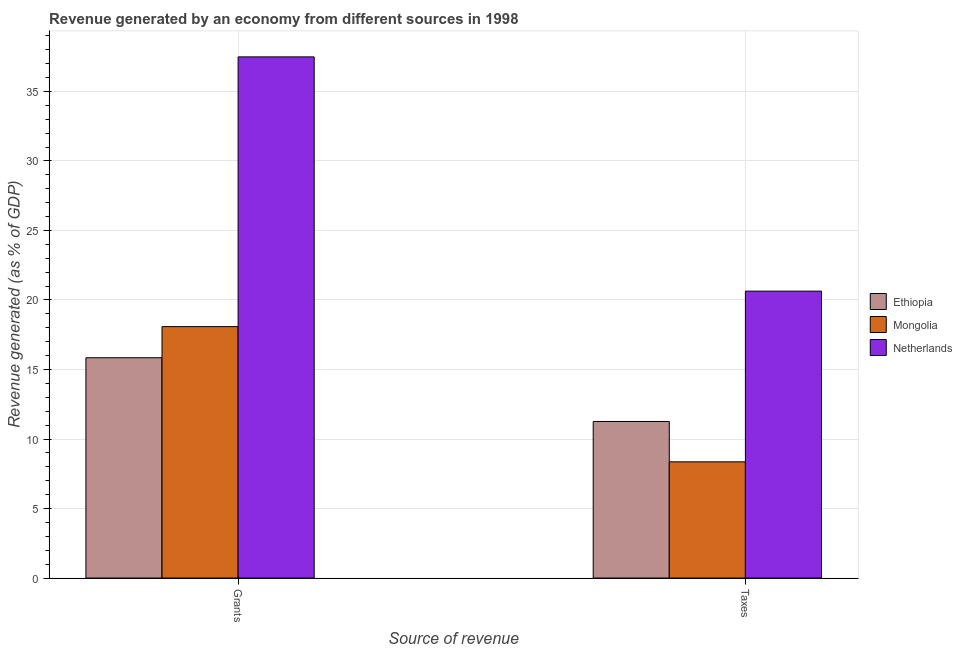How many groups of bars are there?
Provide a succinct answer. 2. Are the number of bars per tick equal to the number of legend labels?
Offer a terse response. Yes. How many bars are there on the 2nd tick from the left?
Keep it short and to the point. 3. How many bars are there on the 1st tick from the right?
Make the answer very short. 3. What is the label of the 1st group of bars from the left?
Your answer should be compact. Grants. What is the revenue generated by grants in Ethiopia?
Provide a short and direct response. 15.85. Across all countries, what is the maximum revenue generated by taxes?
Make the answer very short. 20.64. Across all countries, what is the minimum revenue generated by taxes?
Ensure brevity in your answer.  8.36. In which country was the revenue generated by taxes maximum?
Your answer should be compact. Netherlands. In which country was the revenue generated by taxes minimum?
Ensure brevity in your answer.  Mongolia. What is the total revenue generated by taxes in the graph?
Make the answer very short. 40.26. What is the difference between the revenue generated by taxes in Ethiopia and that in Netherlands?
Offer a terse response. -9.38. What is the difference between the revenue generated by taxes in Mongolia and the revenue generated by grants in Netherlands?
Your response must be concise. -29.13. What is the average revenue generated by taxes per country?
Offer a very short reply. 13.42. What is the difference between the revenue generated by taxes and revenue generated by grants in Mongolia?
Ensure brevity in your answer.  -9.73. In how many countries, is the revenue generated by grants greater than 4 %?
Your answer should be compact. 3. What is the ratio of the revenue generated by taxes in Mongolia to that in Ethiopia?
Your answer should be compact. 0.74. What does the 2nd bar from the left in Taxes represents?
Provide a short and direct response. Mongolia. What does the 2nd bar from the right in Taxes represents?
Keep it short and to the point. Mongolia. Are all the bars in the graph horizontal?
Give a very brief answer. No. How many countries are there in the graph?
Your response must be concise. 3. What is the difference between two consecutive major ticks on the Y-axis?
Give a very brief answer. 5. Are the values on the major ticks of Y-axis written in scientific E-notation?
Your answer should be compact. No. Does the graph contain any zero values?
Provide a succinct answer. No. How many legend labels are there?
Your answer should be compact. 3. What is the title of the graph?
Offer a terse response. Revenue generated by an economy from different sources in 1998. What is the label or title of the X-axis?
Your answer should be very brief. Source of revenue. What is the label or title of the Y-axis?
Keep it short and to the point. Revenue generated (as % of GDP). What is the Revenue generated (as % of GDP) in Ethiopia in Grants?
Provide a short and direct response. 15.85. What is the Revenue generated (as % of GDP) in Mongolia in Grants?
Provide a short and direct response. 18.08. What is the Revenue generated (as % of GDP) in Netherlands in Grants?
Make the answer very short. 37.49. What is the Revenue generated (as % of GDP) of Ethiopia in Taxes?
Offer a terse response. 11.26. What is the Revenue generated (as % of GDP) of Mongolia in Taxes?
Your answer should be very brief. 8.36. What is the Revenue generated (as % of GDP) in Netherlands in Taxes?
Ensure brevity in your answer.  20.64. Across all Source of revenue, what is the maximum Revenue generated (as % of GDP) of Ethiopia?
Offer a very short reply. 15.85. Across all Source of revenue, what is the maximum Revenue generated (as % of GDP) of Mongolia?
Provide a succinct answer. 18.08. Across all Source of revenue, what is the maximum Revenue generated (as % of GDP) in Netherlands?
Give a very brief answer. 37.49. Across all Source of revenue, what is the minimum Revenue generated (as % of GDP) in Ethiopia?
Make the answer very short. 11.26. Across all Source of revenue, what is the minimum Revenue generated (as % of GDP) of Mongolia?
Ensure brevity in your answer.  8.36. Across all Source of revenue, what is the minimum Revenue generated (as % of GDP) in Netherlands?
Keep it short and to the point. 20.64. What is the total Revenue generated (as % of GDP) of Ethiopia in the graph?
Your response must be concise. 27.11. What is the total Revenue generated (as % of GDP) of Mongolia in the graph?
Give a very brief answer. 26.44. What is the total Revenue generated (as % of GDP) in Netherlands in the graph?
Offer a terse response. 58.13. What is the difference between the Revenue generated (as % of GDP) in Ethiopia in Grants and that in Taxes?
Provide a succinct answer. 4.58. What is the difference between the Revenue generated (as % of GDP) in Mongolia in Grants and that in Taxes?
Your answer should be compact. 9.73. What is the difference between the Revenue generated (as % of GDP) in Netherlands in Grants and that in Taxes?
Your answer should be very brief. 16.85. What is the difference between the Revenue generated (as % of GDP) in Ethiopia in Grants and the Revenue generated (as % of GDP) in Mongolia in Taxes?
Give a very brief answer. 7.49. What is the difference between the Revenue generated (as % of GDP) in Ethiopia in Grants and the Revenue generated (as % of GDP) in Netherlands in Taxes?
Your response must be concise. -4.79. What is the difference between the Revenue generated (as % of GDP) in Mongolia in Grants and the Revenue generated (as % of GDP) in Netherlands in Taxes?
Your answer should be compact. -2.55. What is the average Revenue generated (as % of GDP) of Ethiopia per Source of revenue?
Provide a succinct answer. 13.55. What is the average Revenue generated (as % of GDP) in Mongolia per Source of revenue?
Your answer should be very brief. 13.22. What is the average Revenue generated (as % of GDP) in Netherlands per Source of revenue?
Provide a short and direct response. 29.06. What is the difference between the Revenue generated (as % of GDP) of Ethiopia and Revenue generated (as % of GDP) of Mongolia in Grants?
Offer a very short reply. -2.24. What is the difference between the Revenue generated (as % of GDP) of Ethiopia and Revenue generated (as % of GDP) of Netherlands in Grants?
Offer a very short reply. -21.64. What is the difference between the Revenue generated (as % of GDP) of Mongolia and Revenue generated (as % of GDP) of Netherlands in Grants?
Make the answer very short. -19.4. What is the difference between the Revenue generated (as % of GDP) of Ethiopia and Revenue generated (as % of GDP) of Mongolia in Taxes?
Provide a succinct answer. 2.9. What is the difference between the Revenue generated (as % of GDP) in Ethiopia and Revenue generated (as % of GDP) in Netherlands in Taxes?
Provide a short and direct response. -9.38. What is the difference between the Revenue generated (as % of GDP) in Mongolia and Revenue generated (as % of GDP) in Netherlands in Taxes?
Provide a short and direct response. -12.28. What is the ratio of the Revenue generated (as % of GDP) in Ethiopia in Grants to that in Taxes?
Provide a short and direct response. 1.41. What is the ratio of the Revenue generated (as % of GDP) of Mongolia in Grants to that in Taxes?
Offer a very short reply. 2.16. What is the ratio of the Revenue generated (as % of GDP) in Netherlands in Grants to that in Taxes?
Your answer should be compact. 1.82. What is the difference between the highest and the second highest Revenue generated (as % of GDP) in Ethiopia?
Make the answer very short. 4.58. What is the difference between the highest and the second highest Revenue generated (as % of GDP) of Mongolia?
Provide a succinct answer. 9.73. What is the difference between the highest and the second highest Revenue generated (as % of GDP) of Netherlands?
Ensure brevity in your answer.  16.85. What is the difference between the highest and the lowest Revenue generated (as % of GDP) in Ethiopia?
Offer a very short reply. 4.58. What is the difference between the highest and the lowest Revenue generated (as % of GDP) of Mongolia?
Provide a short and direct response. 9.73. What is the difference between the highest and the lowest Revenue generated (as % of GDP) of Netherlands?
Provide a succinct answer. 16.85. 